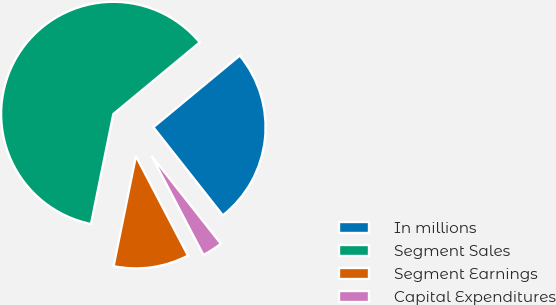<chart> <loc_0><loc_0><loc_500><loc_500><pie_chart><fcel>In millions<fcel>Segment Sales<fcel>Segment Earnings<fcel>Capital Expenditures<nl><fcel>25.39%<fcel>60.79%<fcel>10.87%<fcel>2.95%<nl></chart> 